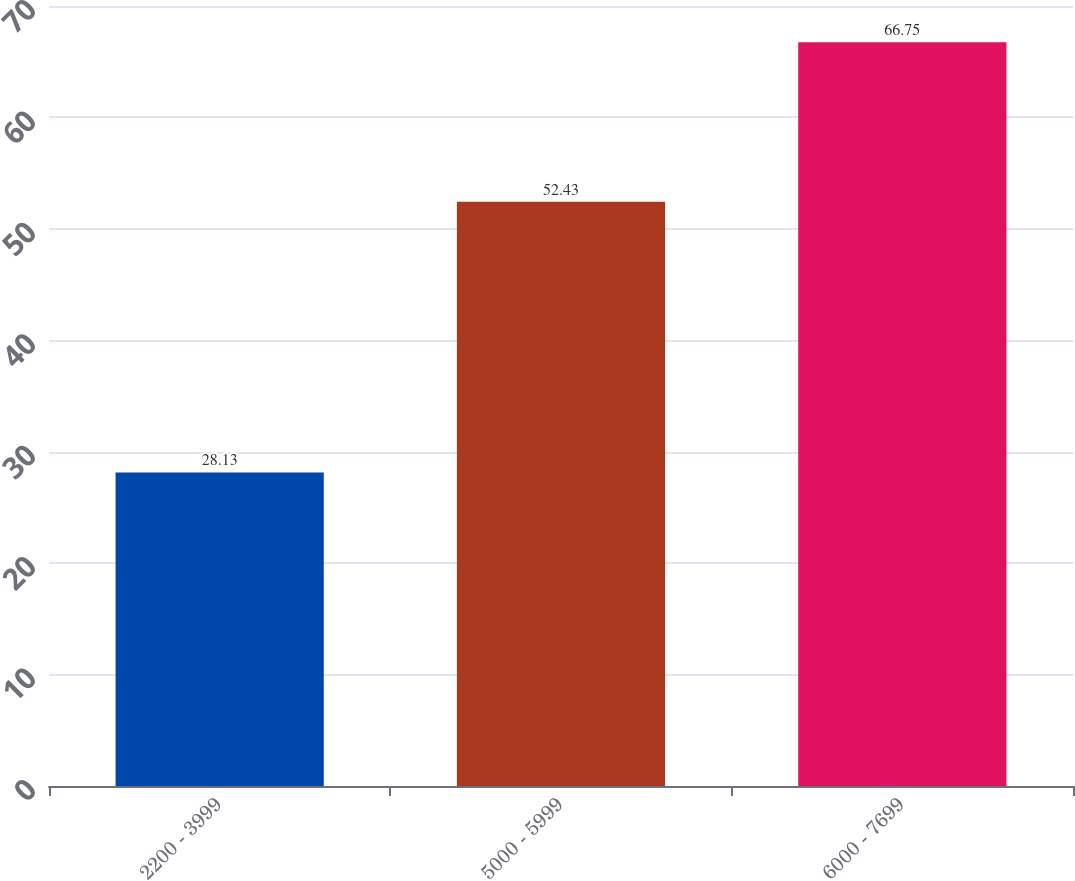Convert chart to OTSL. <chart><loc_0><loc_0><loc_500><loc_500><bar_chart><fcel>2200 - 3999<fcel>5000 - 5999<fcel>6000 - 7699<nl><fcel>28.13<fcel>52.43<fcel>66.75<nl></chart> 